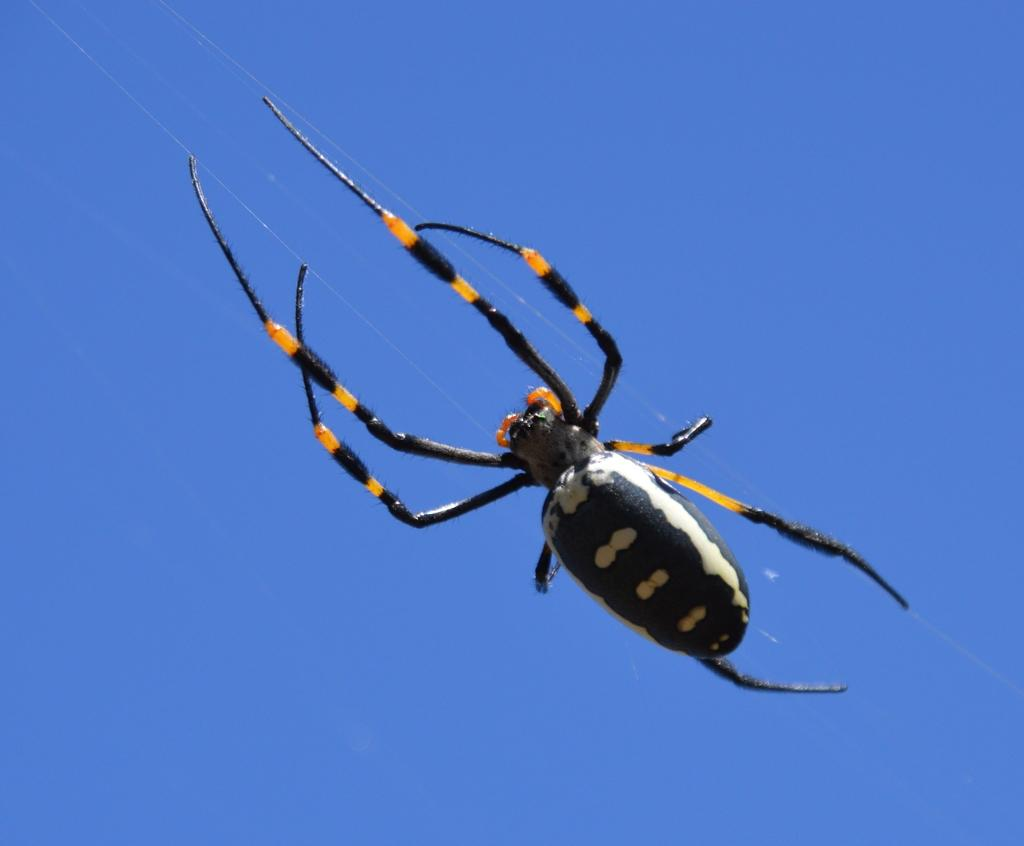What is the main subject of the picture? The main subject of the picture is a spider. What color is the background of the image? The background of the image is blue in color. How many pens are visible in the image? There are no pens present in the image. What type of wealth is depicted in the image? There is no depiction of wealth in the image; it features a spider against a blue background. 